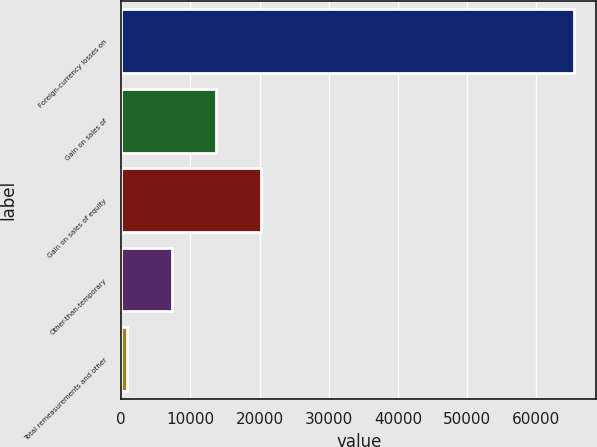<chart> <loc_0><loc_0><loc_500><loc_500><bar_chart><fcel>Foreign-currency losses on<fcel>Gain on sales of<fcel>Gain on sales of equity<fcel>Other-than-temporary<fcel>Total remeasurements and other<nl><fcel>65375<fcel>13734.2<fcel>20189.3<fcel>7279.1<fcel>824<nl></chart> 